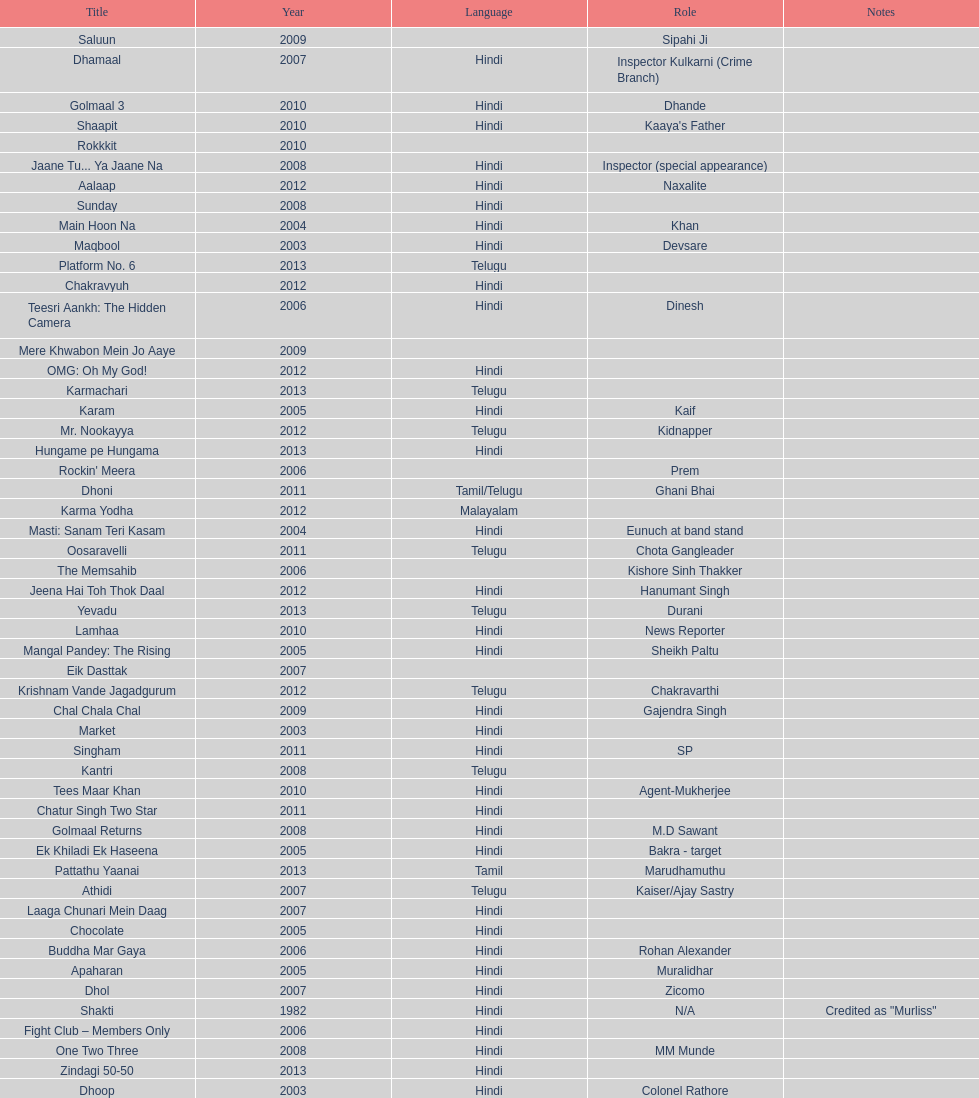How many characters has this actor portrayed? 36. 